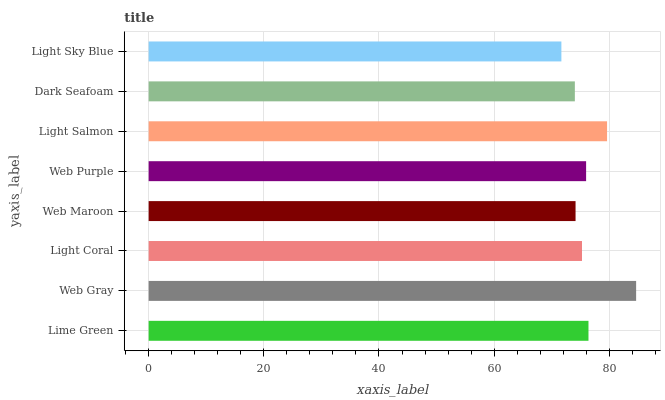Is Light Sky Blue the minimum?
Answer yes or no. Yes. Is Web Gray the maximum?
Answer yes or no. Yes. Is Light Coral the minimum?
Answer yes or no. No. Is Light Coral the maximum?
Answer yes or no. No. Is Web Gray greater than Light Coral?
Answer yes or no. Yes. Is Light Coral less than Web Gray?
Answer yes or no. Yes. Is Light Coral greater than Web Gray?
Answer yes or no. No. Is Web Gray less than Light Coral?
Answer yes or no. No. Is Web Purple the high median?
Answer yes or no. Yes. Is Light Coral the low median?
Answer yes or no. Yes. Is Dark Seafoam the high median?
Answer yes or no. No. Is Light Salmon the low median?
Answer yes or no. No. 